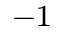<formula> <loc_0><loc_0><loc_500><loc_500>^ { - 1 }</formula> 